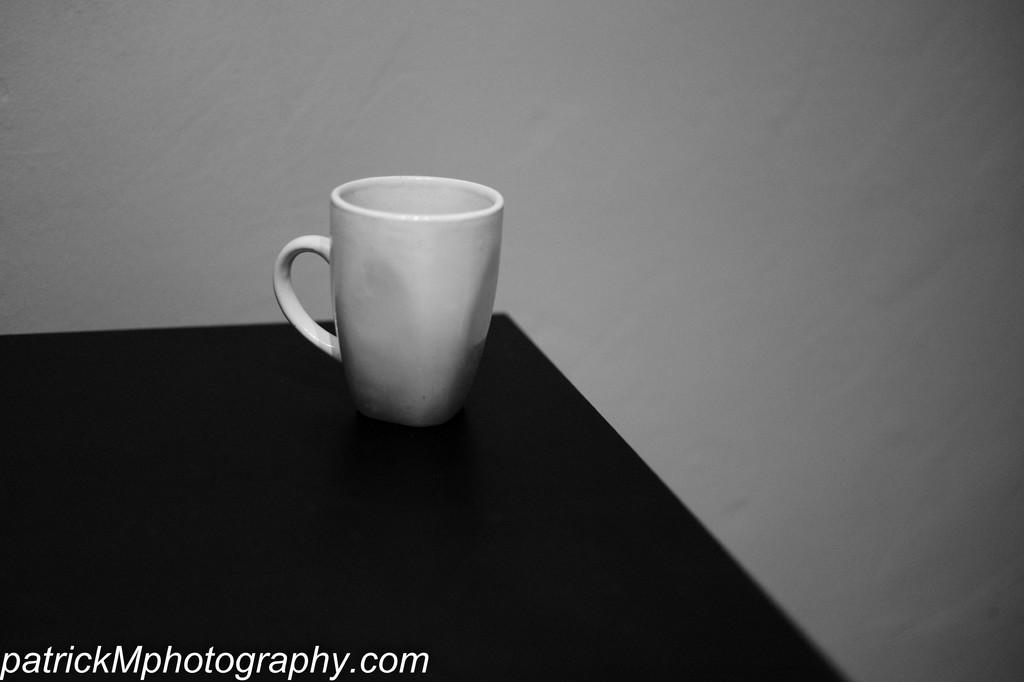What is the color scheme of the image? The image is black and white. What type of furniture is present in the image? There is a table in the image. What object can be seen on the table? There is a white color cup on the table. What type of feeling does the cup convey in the image? The image is black and white, so it does not convey feelings. Additionally, the cup is an inanimate object and cannot have feelings. 